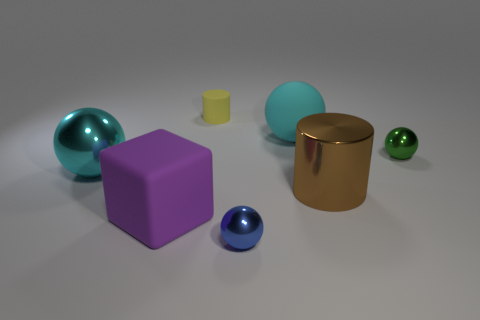How might the arrangement of these objects tell a story or suggest a theme? The arrangement of these objects might evoke themes of diversity and contrast. Each object is distinct in its form and texture, encouraging contemplation on variety and uniqueness. Additionally, the positioning of the objects, with some closer and others further away, can incite reflections on perspective and how proximity can affect perception—elements often present in storytelling and thematic exploration. 